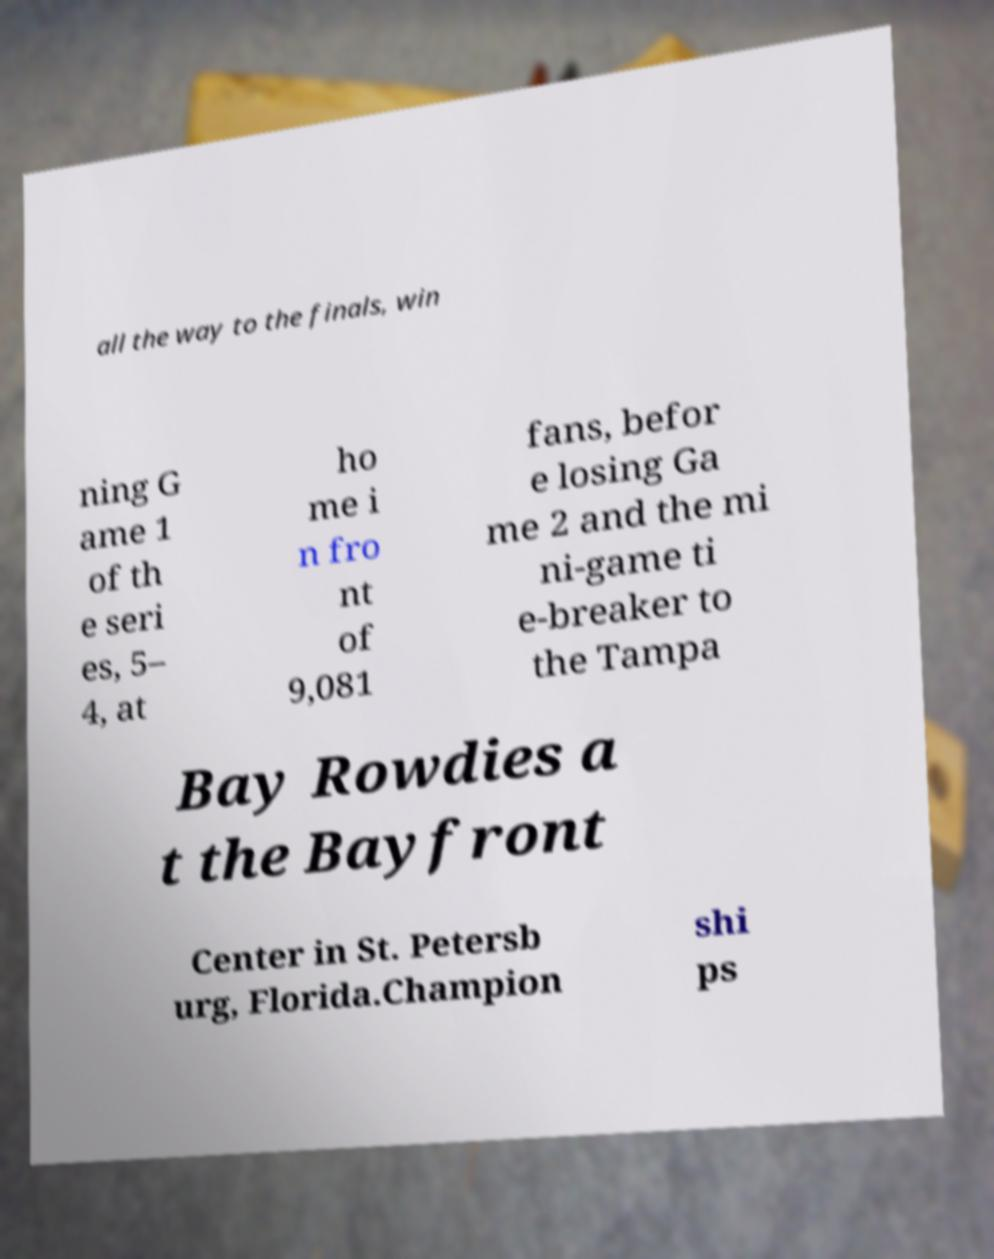Could you extract and type out the text from this image? all the way to the finals, win ning G ame 1 of th e seri es, 5– 4, at ho me i n fro nt of 9,081 fans, befor e losing Ga me 2 and the mi ni-game ti e-breaker to the Tampa Bay Rowdies a t the Bayfront Center in St. Petersb urg, Florida.Champion shi ps 